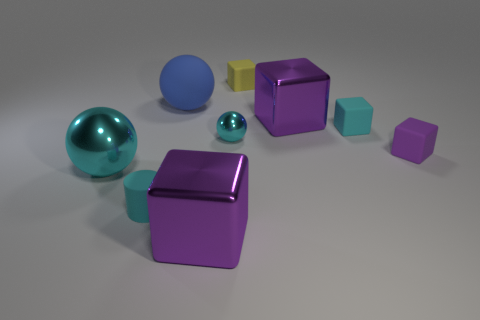Can you tell me the color composition in the image? Certainly! The image showcases objects in various hues. There are two shiny teal objects, three purple objects with matte finishes (two are cubes, and one is an octahedron), a single glossy blue sphere, and a small yellow cube. This gives us a cool color palette, with teal and purple dominating the scene, complemented by the warm touch of the yellow cube. 